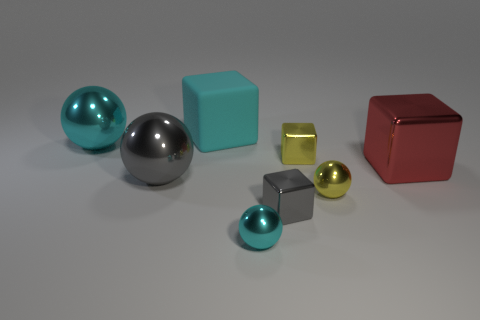Subtract all small yellow balls. How many balls are left? 3 Add 1 tiny yellow spheres. How many objects exist? 9 Subtract all cyan balls. How many balls are left? 2 Subtract all cyan cubes. How many gray spheres are left? 1 Subtract all large things. Subtract all small purple balls. How many objects are left? 4 Add 8 cyan matte cubes. How many cyan matte cubes are left? 9 Add 7 large red metal cubes. How many large red metal cubes exist? 8 Subtract 0 green balls. How many objects are left? 8 Subtract 2 cubes. How many cubes are left? 2 Subtract all cyan cubes. Subtract all purple cylinders. How many cubes are left? 3 